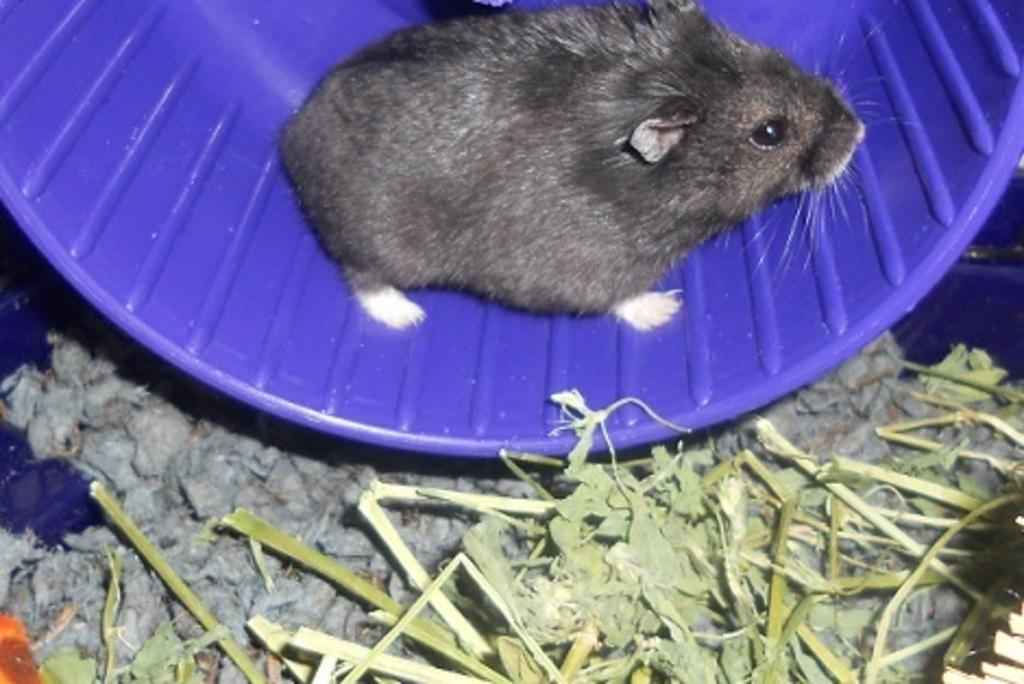What animal is present in the image? There is a rat in the image. What color is the surface the rat is on? The rat is on a purple surface. What type of vegetation is near the rat? There is grass beside the rat. How many babies are in the image? There are no babies present in the image; it features a rat on a purple surface with grass beside it. 